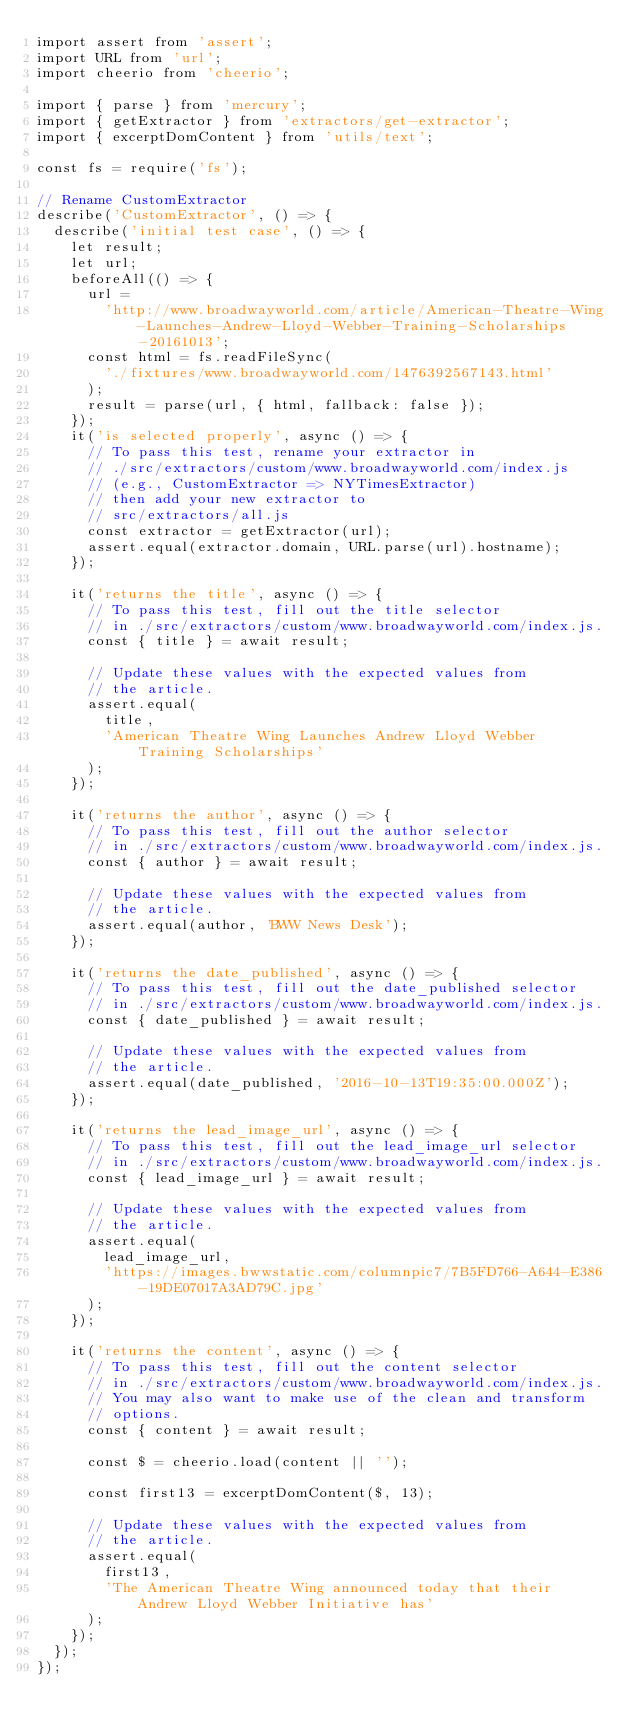Convert code to text. <code><loc_0><loc_0><loc_500><loc_500><_JavaScript_>import assert from 'assert';
import URL from 'url';
import cheerio from 'cheerio';

import { parse } from 'mercury';
import { getExtractor } from 'extractors/get-extractor';
import { excerptDomContent } from 'utils/text';

const fs = require('fs');

// Rename CustomExtractor
describe('CustomExtractor', () => {
  describe('initial test case', () => {
    let result;
    let url;
    beforeAll(() => {
      url =
        'http://www.broadwayworld.com/article/American-Theatre-Wing-Launches-Andrew-Lloyd-Webber-Training-Scholarships-20161013';
      const html = fs.readFileSync(
        './fixtures/www.broadwayworld.com/1476392567143.html'
      );
      result = parse(url, { html, fallback: false });
    });
    it('is selected properly', async () => {
      // To pass this test, rename your extractor in
      // ./src/extractors/custom/www.broadwayworld.com/index.js
      // (e.g., CustomExtractor => NYTimesExtractor)
      // then add your new extractor to
      // src/extractors/all.js
      const extractor = getExtractor(url);
      assert.equal(extractor.domain, URL.parse(url).hostname);
    });

    it('returns the title', async () => {
      // To pass this test, fill out the title selector
      // in ./src/extractors/custom/www.broadwayworld.com/index.js.
      const { title } = await result;

      // Update these values with the expected values from
      // the article.
      assert.equal(
        title,
        'American Theatre Wing Launches Andrew Lloyd Webber Training Scholarships'
      );
    });

    it('returns the author', async () => {
      // To pass this test, fill out the author selector
      // in ./src/extractors/custom/www.broadwayworld.com/index.js.
      const { author } = await result;

      // Update these values with the expected values from
      // the article.
      assert.equal(author, 'BWW News Desk');
    });

    it('returns the date_published', async () => {
      // To pass this test, fill out the date_published selector
      // in ./src/extractors/custom/www.broadwayworld.com/index.js.
      const { date_published } = await result;

      // Update these values with the expected values from
      // the article.
      assert.equal(date_published, '2016-10-13T19:35:00.000Z');
    });

    it('returns the lead_image_url', async () => {
      // To pass this test, fill out the lead_image_url selector
      // in ./src/extractors/custom/www.broadwayworld.com/index.js.
      const { lead_image_url } = await result;

      // Update these values with the expected values from
      // the article.
      assert.equal(
        lead_image_url,
        'https://images.bwwstatic.com/columnpic7/7B5FD766-A644-E386-19DE07017A3AD79C.jpg'
      );
    });

    it('returns the content', async () => {
      // To pass this test, fill out the content selector
      // in ./src/extractors/custom/www.broadwayworld.com/index.js.
      // You may also want to make use of the clean and transform
      // options.
      const { content } = await result;

      const $ = cheerio.load(content || '');

      const first13 = excerptDomContent($, 13);

      // Update these values with the expected values from
      // the article.
      assert.equal(
        first13,
        'The American Theatre Wing announced today that their Andrew Lloyd Webber Initiative has'
      );
    });
  });
});
</code> 